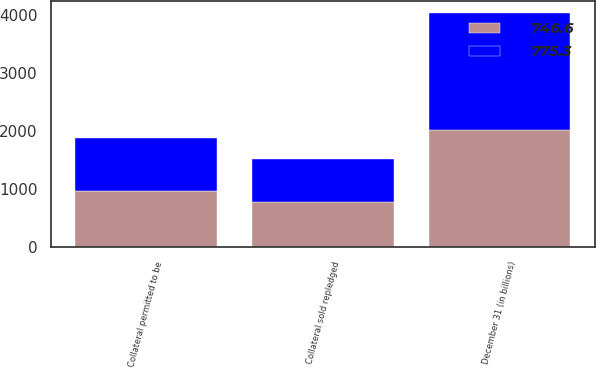Convert chart. <chart><loc_0><loc_0><loc_500><loc_500><stacked_bar_chart><ecel><fcel>December 31 (in billions)<fcel>Collateral permitted to be<fcel>Collateral sold repledged<nl><fcel>746.6<fcel>2017<fcel>968.8<fcel>775.3<nl><fcel>775.3<fcel>2016<fcel>914.1<fcel>746.6<nl></chart> 